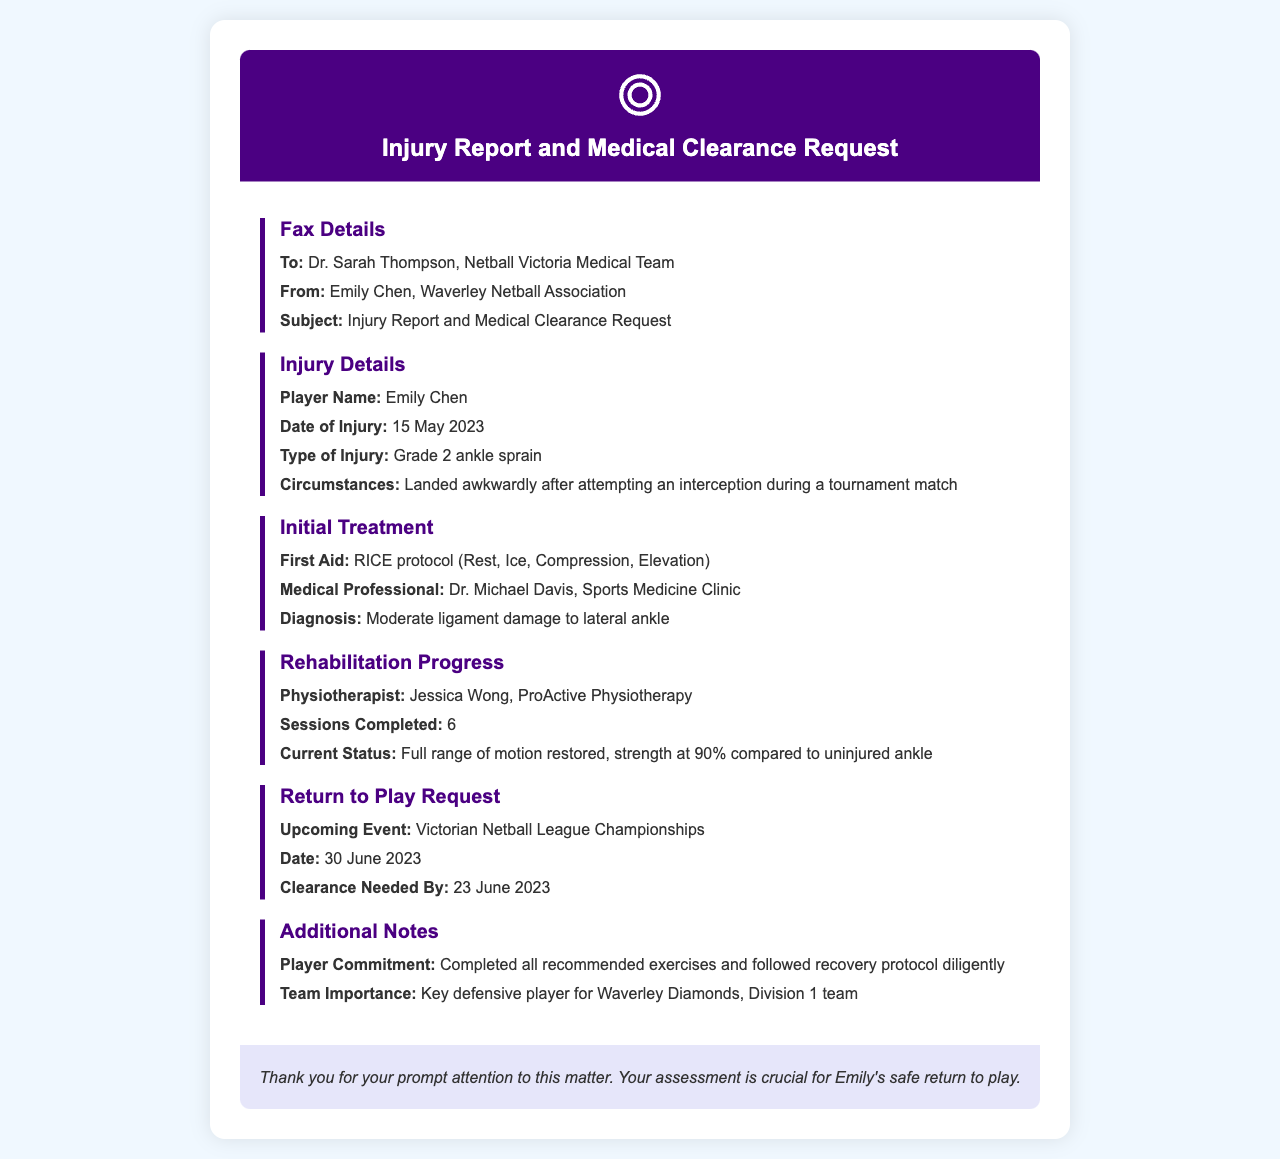What is the name of the player? The player's name is provided in the injury details section of the document.
Answer: Emily Chen What type of injury did the player sustain? The document specifies the type of injury in the injury details section.
Answer: Grade 2 ankle sprain When did the injury occur? The date of the injury is clearly stated in the injury details section.
Answer: 15 May 2023 Who provided the initial medical treatment? The medical professional who treated the injury is mentioned in the initial treatment section.
Answer: Dr. Michael Davis What is the player's current strength compared to the uninjured ankle? The current strength is noted in the rehabilitation progress section.
Answer: 90% What is the date by which medical clearance is needed? The deadline for medical clearance is indicated in the return to play request section.
Answer: 23 June 2023 What protocol was followed for initial treatment? The document lists the initial treatment protocol in the initial treatment section.
Answer: RICE protocol How many physiotherapy sessions has the player completed? The number of sessions completed is mentioned in the rehabilitation progress section.
Answer: 6 What is the upcoming event the player aims to participate in? The upcoming event is specified in the return to play request section.
Answer: Victorian Netball League Championships 